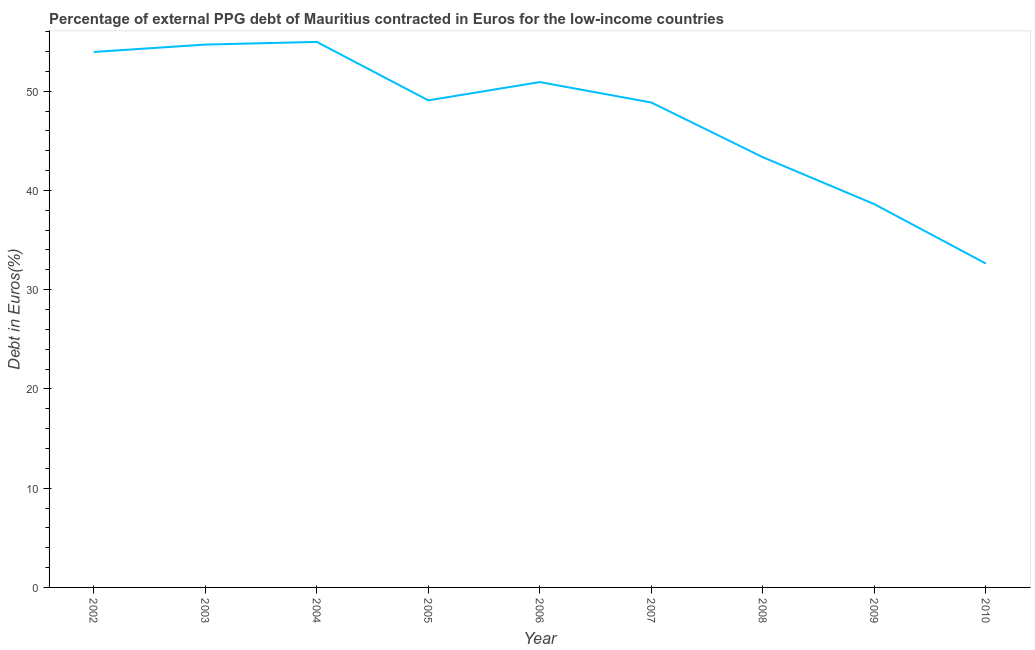What is the currency composition of ppg debt in 2005?
Offer a very short reply. 49.07. Across all years, what is the maximum currency composition of ppg debt?
Provide a short and direct response. 54.96. Across all years, what is the minimum currency composition of ppg debt?
Offer a terse response. 32.63. In which year was the currency composition of ppg debt minimum?
Make the answer very short. 2010. What is the sum of the currency composition of ppg debt?
Provide a succinct answer. 427.05. What is the difference between the currency composition of ppg debt in 2002 and 2006?
Ensure brevity in your answer.  3.04. What is the average currency composition of ppg debt per year?
Give a very brief answer. 47.45. What is the median currency composition of ppg debt?
Make the answer very short. 49.07. Do a majority of the years between 2009 and 2007 (inclusive) have currency composition of ppg debt greater than 34 %?
Ensure brevity in your answer.  No. What is the ratio of the currency composition of ppg debt in 2003 to that in 2007?
Offer a terse response. 1.12. Is the currency composition of ppg debt in 2008 less than that in 2009?
Your answer should be compact. No. What is the difference between the highest and the second highest currency composition of ppg debt?
Keep it short and to the point. 0.27. Is the sum of the currency composition of ppg debt in 2003 and 2007 greater than the maximum currency composition of ppg debt across all years?
Your answer should be compact. Yes. What is the difference between the highest and the lowest currency composition of ppg debt?
Offer a very short reply. 22.33. Does the currency composition of ppg debt monotonically increase over the years?
Keep it short and to the point. No. Are the values on the major ticks of Y-axis written in scientific E-notation?
Provide a succinct answer. No. Does the graph contain any zero values?
Offer a terse response. No. What is the title of the graph?
Give a very brief answer. Percentage of external PPG debt of Mauritius contracted in Euros for the low-income countries. What is the label or title of the X-axis?
Offer a terse response. Year. What is the label or title of the Y-axis?
Offer a terse response. Debt in Euros(%). What is the Debt in Euros(%) of 2002?
Provide a short and direct response. 53.95. What is the Debt in Euros(%) of 2003?
Keep it short and to the point. 54.69. What is the Debt in Euros(%) in 2004?
Ensure brevity in your answer.  54.96. What is the Debt in Euros(%) of 2005?
Ensure brevity in your answer.  49.07. What is the Debt in Euros(%) of 2006?
Provide a short and direct response. 50.92. What is the Debt in Euros(%) in 2007?
Your response must be concise. 48.86. What is the Debt in Euros(%) in 2008?
Provide a short and direct response. 43.35. What is the Debt in Euros(%) of 2009?
Give a very brief answer. 38.61. What is the Debt in Euros(%) of 2010?
Keep it short and to the point. 32.63. What is the difference between the Debt in Euros(%) in 2002 and 2003?
Your answer should be very brief. -0.74. What is the difference between the Debt in Euros(%) in 2002 and 2004?
Offer a terse response. -1.01. What is the difference between the Debt in Euros(%) in 2002 and 2005?
Provide a short and direct response. 4.88. What is the difference between the Debt in Euros(%) in 2002 and 2006?
Your answer should be very brief. 3.04. What is the difference between the Debt in Euros(%) in 2002 and 2007?
Your answer should be very brief. 5.1. What is the difference between the Debt in Euros(%) in 2002 and 2008?
Your answer should be very brief. 10.61. What is the difference between the Debt in Euros(%) in 2002 and 2009?
Ensure brevity in your answer.  15.34. What is the difference between the Debt in Euros(%) in 2002 and 2010?
Provide a succinct answer. 21.32. What is the difference between the Debt in Euros(%) in 2003 and 2004?
Your answer should be compact. -0.27. What is the difference between the Debt in Euros(%) in 2003 and 2005?
Provide a succinct answer. 5.62. What is the difference between the Debt in Euros(%) in 2003 and 2006?
Your response must be concise. 3.78. What is the difference between the Debt in Euros(%) in 2003 and 2007?
Provide a short and direct response. 5.84. What is the difference between the Debt in Euros(%) in 2003 and 2008?
Give a very brief answer. 11.35. What is the difference between the Debt in Euros(%) in 2003 and 2009?
Offer a terse response. 16.08. What is the difference between the Debt in Euros(%) in 2003 and 2010?
Give a very brief answer. 22.06. What is the difference between the Debt in Euros(%) in 2004 and 2005?
Make the answer very short. 5.89. What is the difference between the Debt in Euros(%) in 2004 and 2006?
Give a very brief answer. 4.05. What is the difference between the Debt in Euros(%) in 2004 and 2007?
Your response must be concise. 6.11. What is the difference between the Debt in Euros(%) in 2004 and 2008?
Give a very brief answer. 11.62. What is the difference between the Debt in Euros(%) in 2004 and 2009?
Your response must be concise. 16.35. What is the difference between the Debt in Euros(%) in 2004 and 2010?
Provide a succinct answer. 22.33. What is the difference between the Debt in Euros(%) in 2005 and 2006?
Provide a succinct answer. -1.84. What is the difference between the Debt in Euros(%) in 2005 and 2007?
Your response must be concise. 0.22. What is the difference between the Debt in Euros(%) in 2005 and 2008?
Your answer should be very brief. 5.73. What is the difference between the Debt in Euros(%) in 2005 and 2009?
Offer a terse response. 10.46. What is the difference between the Debt in Euros(%) in 2005 and 2010?
Provide a succinct answer. 16.44. What is the difference between the Debt in Euros(%) in 2006 and 2007?
Offer a very short reply. 2.06. What is the difference between the Debt in Euros(%) in 2006 and 2008?
Provide a succinct answer. 7.57. What is the difference between the Debt in Euros(%) in 2006 and 2009?
Provide a short and direct response. 12.3. What is the difference between the Debt in Euros(%) in 2006 and 2010?
Make the answer very short. 18.28. What is the difference between the Debt in Euros(%) in 2007 and 2008?
Provide a short and direct response. 5.51. What is the difference between the Debt in Euros(%) in 2007 and 2009?
Give a very brief answer. 10.24. What is the difference between the Debt in Euros(%) in 2007 and 2010?
Offer a very short reply. 16.22. What is the difference between the Debt in Euros(%) in 2008 and 2009?
Your response must be concise. 4.73. What is the difference between the Debt in Euros(%) in 2008 and 2010?
Offer a very short reply. 10.71. What is the difference between the Debt in Euros(%) in 2009 and 2010?
Make the answer very short. 5.98. What is the ratio of the Debt in Euros(%) in 2002 to that in 2005?
Make the answer very short. 1.1. What is the ratio of the Debt in Euros(%) in 2002 to that in 2006?
Keep it short and to the point. 1.06. What is the ratio of the Debt in Euros(%) in 2002 to that in 2007?
Your response must be concise. 1.1. What is the ratio of the Debt in Euros(%) in 2002 to that in 2008?
Provide a succinct answer. 1.25. What is the ratio of the Debt in Euros(%) in 2002 to that in 2009?
Give a very brief answer. 1.4. What is the ratio of the Debt in Euros(%) in 2002 to that in 2010?
Your answer should be very brief. 1.65. What is the ratio of the Debt in Euros(%) in 2003 to that in 2005?
Your answer should be compact. 1.11. What is the ratio of the Debt in Euros(%) in 2003 to that in 2006?
Your answer should be compact. 1.07. What is the ratio of the Debt in Euros(%) in 2003 to that in 2007?
Ensure brevity in your answer.  1.12. What is the ratio of the Debt in Euros(%) in 2003 to that in 2008?
Your answer should be compact. 1.26. What is the ratio of the Debt in Euros(%) in 2003 to that in 2009?
Offer a very short reply. 1.42. What is the ratio of the Debt in Euros(%) in 2003 to that in 2010?
Ensure brevity in your answer.  1.68. What is the ratio of the Debt in Euros(%) in 2004 to that in 2005?
Make the answer very short. 1.12. What is the ratio of the Debt in Euros(%) in 2004 to that in 2006?
Offer a very short reply. 1.08. What is the ratio of the Debt in Euros(%) in 2004 to that in 2008?
Offer a terse response. 1.27. What is the ratio of the Debt in Euros(%) in 2004 to that in 2009?
Keep it short and to the point. 1.42. What is the ratio of the Debt in Euros(%) in 2004 to that in 2010?
Your answer should be compact. 1.68. What is the ratio of the Debt in Euros(%) in 2005 to that in 2007?
Your response must be concise. 1. What is the ratio of the Debt in Euros(%) in 2005 to that in 2008?
Your answer should be compact. 1.13. What is the ratio of the Debt in Euros(%) in 2005 to that in 2009?
Give a very brief answer. 1.27. What is the ratio of the Debt in Euros(%) in 2005 to that in 2010?
Ensure brevity in your answer.  1.5. What is the ratio of the Debt in Euros(%) in 2006 to that in 2007?
Your response must be concise. 1.04. What is the ratio of the Debt in Euros(%) in 2006 to that in 2008?
Provide a short and direct response. 1.18. What is the ratio of the Debt in Euros(%) in 2006 to that in 2009?
Keep it short and to the point. 1.32. What is the ratio of the Debt in Euros(%) in 2006 to that in 2010?
Keep it short and to the point. 1.56. What is the ratio of the Debt in Euros(%) in 2007 to that in 2008?
Keep it short and to the point. 1.13. What is the ratio of the Debt in Euros(%) in 2007 to that in 2009?
Your answer should be compact. 1.26. What is the ratio of the Debt in Euros(%) in 2007 to that in 2010?
Ensure brevity in your answer.  1.5. What is the ratio of the Debt in Euros(%) in 2008 to that in 2009?
Ensure brevity in your answer.  1.12. What is the ratio of the Debt in Euros(%) in 2008 to that in 2010?
Your answer should be compact. 1.33. What is the ratio of the Debt in Euros(%) in 2009 to that in 2010?
Offer a terse response. 1.18. 